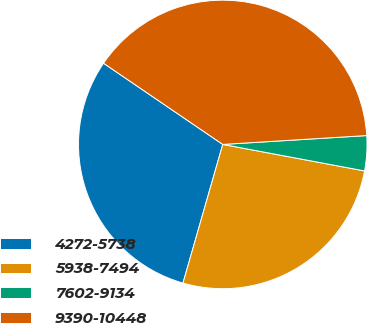Convert chart. <chart><loc_0><loc_0><loc_500><loc_500><pie_chart><fcel>4272-5738<fcel>5938-7494<fcel>7602-9134<fcel>9390-10448<nl><fcel>30.07%<fcel>26.51%<fcel>3.92%<fcel>39.51%<nl></chart> 